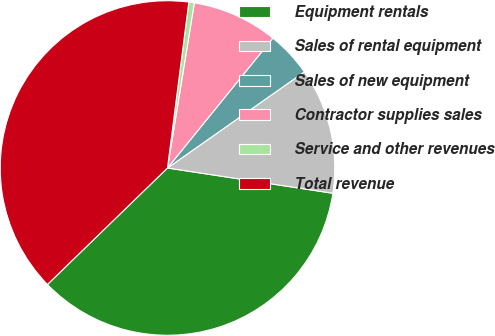Convert chart to OTSL. <chart><loc_0><loc_0><loc_500><loc_500><pie_chart><fcel>Equipment rentals<fcel>Sales of rental equipment<fcel>Sales of new equipment<fcel>Contractor supplies sales<fcel>Service and other revenues<fcel>Total revenue<nl><fcel>35.33%<fcel>12.16%<fcel>4.41%<fcel>8.28%<fcel>0.53%<fcel>39.3%<nl></chart> 